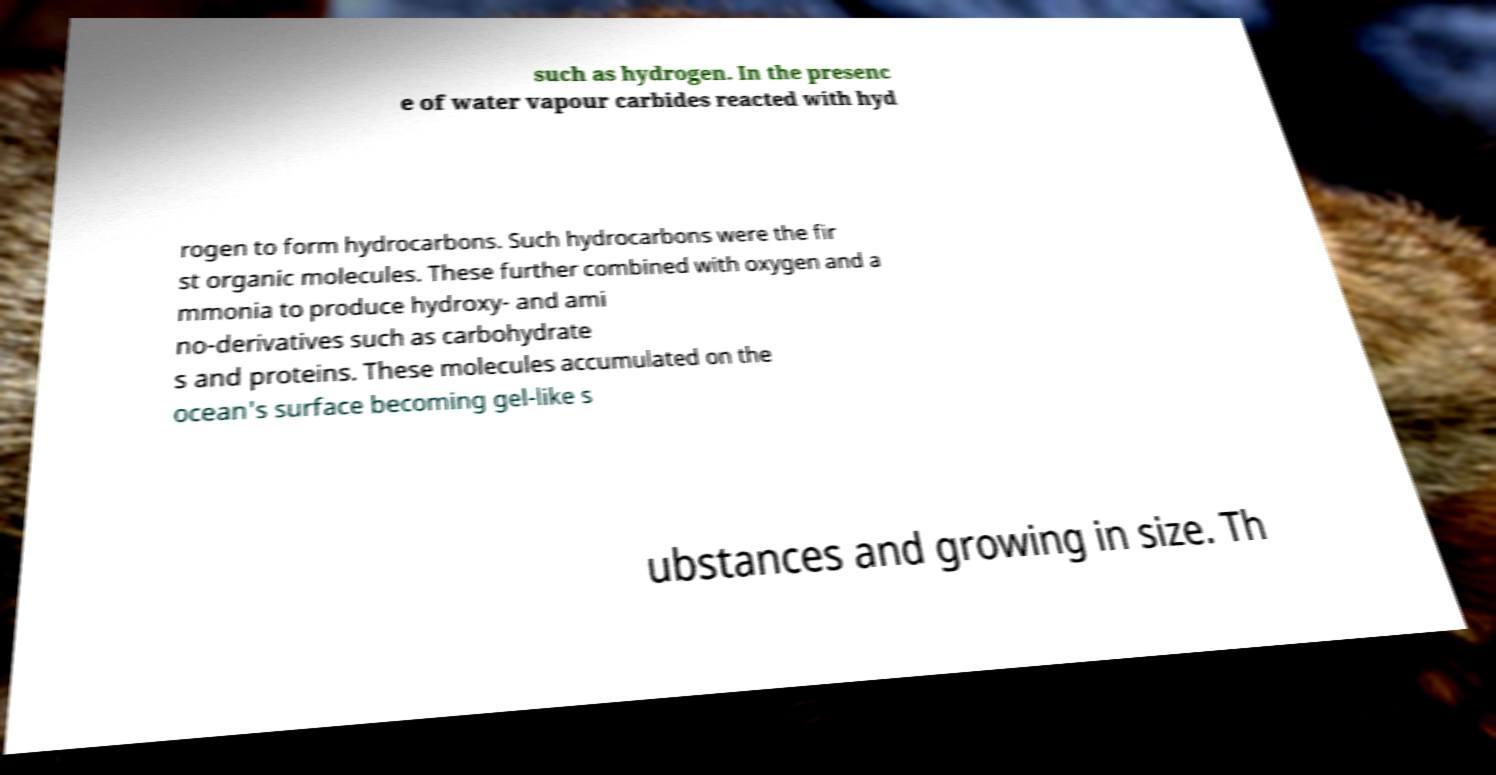Could you assist in decoding the text presented in this image and type it out clearly? such as hydrogen. In the presenc e of water vapour carbides reacted with hyd rogen to form hydrocarbons. Such hydrocarbons were the fir st organic molecules. These further combined with oxygen and a mmonia to produce hydroxy- and ami no-derivatives such as carbohydrate s and proteins. These molecules accumulated on the ocean's surface becoming gel-like s ubstances and growing in size. Th 